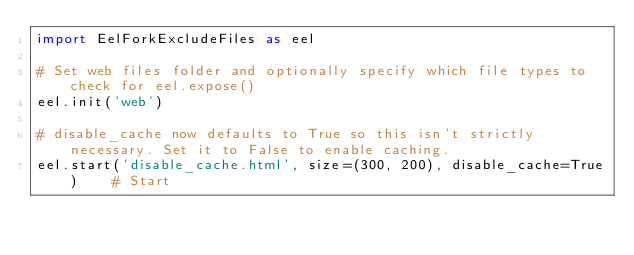<code> <loc_0><loc_0><loc_500><loc_500><_Python_>import EelForkExcludeFiles as eel

# Set web files folder and optionally specify which file types to check for eel.expose()
eel.init('web')

# disable_cache now defaults to True so this isn't strictly necessary. Set it to False to enable caching.
eel.start('disable_cache.html', size=(300, 200), disable_cache=True)    # Start
</code> 